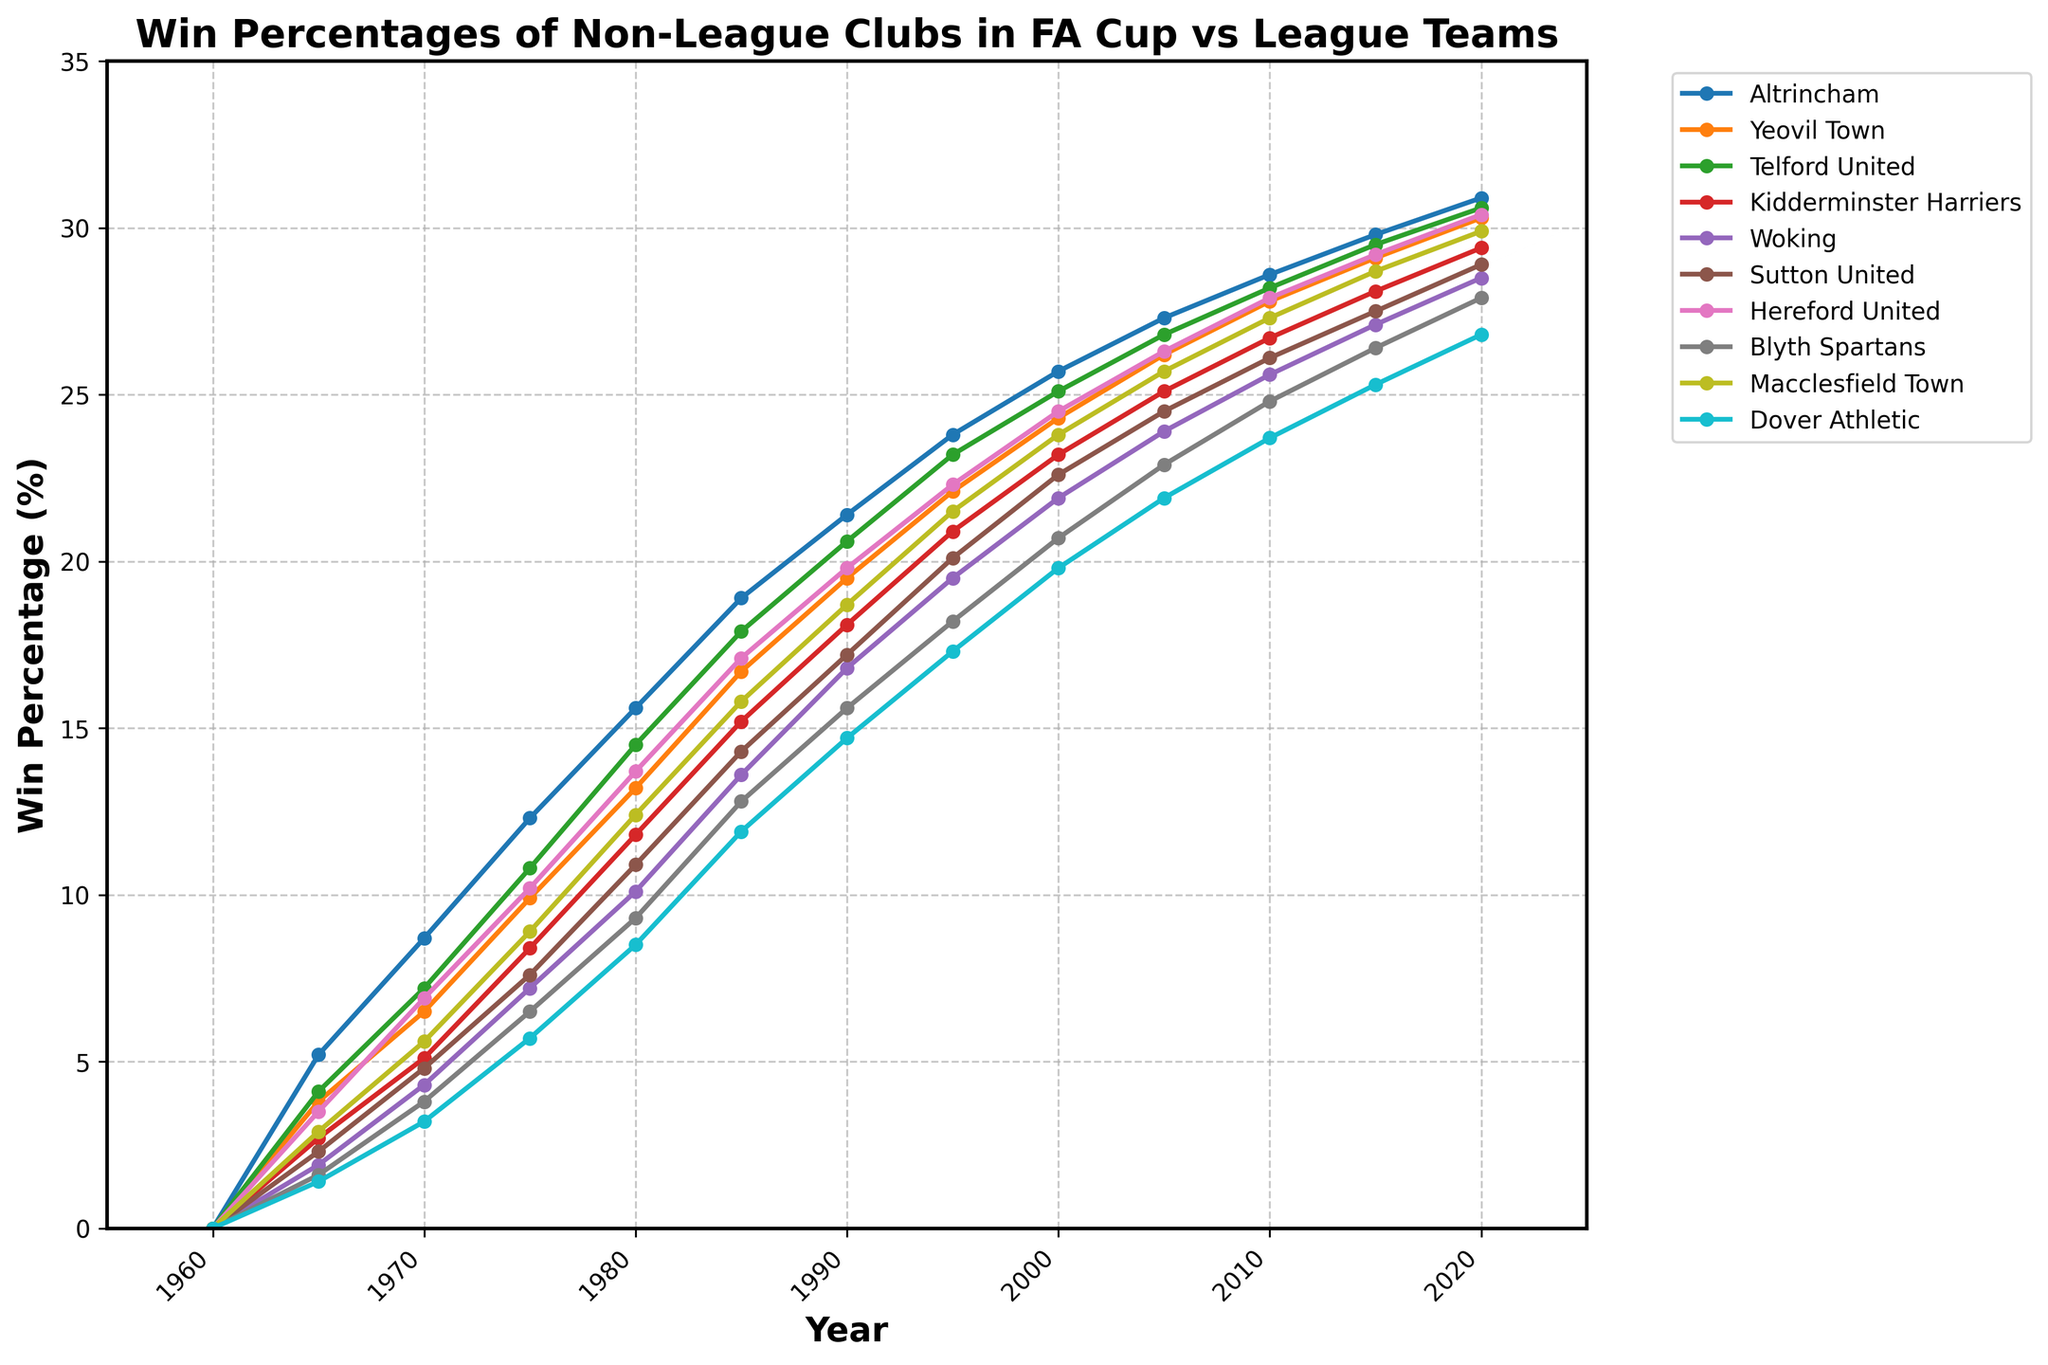what is the win percentage of Altrincham in 1980? Look at the y-axis value for Altrincham's line in 1980. It intersects at approximately 15.6%.
Answer: 15.6% Which club shows the highest win percentage in 2020? Check the y-axis value at 2020 for all lines. The highest is Hereford United at 30.4%.
Answer: Hereford United How does the win percentage of Yeovil Town compare between 1965 and 2015? In 1965, Yeovil Town had a win percentage of 3.8%. In 2015, it rose to 29.1%.
Answer: It increased What is the average win percentage of Macclesfield Town in 1970, 1980, and 1990? The percentages are 5.6%, 12.4%, and 18.7%. (5.6 + 12.4 + 18.7) / 3 = 12.23%.
Answer: 12.23% Did any club have a declining win percentage between 2010 and 2020? Observe the lines from 2010 to 2020. All show an upward trend; thus, no club's win percentage decreased.
Answer: No Which club had a steeper increase in win percentage from 2000 to 2010, Kidderminster Harriers or Woking? Kidderminster Harriers went from 23.2% to 26.7% (a 3.5% increase), while Woking went from 21.9% to 25.6% (a 3.7% increase). Woking had a steeper increase.
Answer: Woking What is the difference in win percentage between Blyth Spartans and Dover Athletic in 2005? Blyth Spartans had a win percentage of 22.9%, and Dover Athletic had 21.9%. The difference is 1%.
Answer: 1% Which club's line is colored blue, and what was its win percentage in 1990? The line colored blue is for Sutton United with a percentage of 17.2%.
Answer: Sutton United, 17.2% How did the win percentage of Hereford United change from 1975 to 1985? In 1975, Hereford United had a percentage of 10.2%, and in 1985 it increased to 17.1%. The change is 17.1% - 10.2% = 6.9%.
Answer: Increased by 6.9% What is the combined win percentage of Altrincham and kidderminster harriers in 1995? The percentages are 23.8% (Altrincham) and 20.9% (Kidderminster Harriers). Adding these gives 23.8 + 20.9 = 44.7%.
Answer: 44.7% 